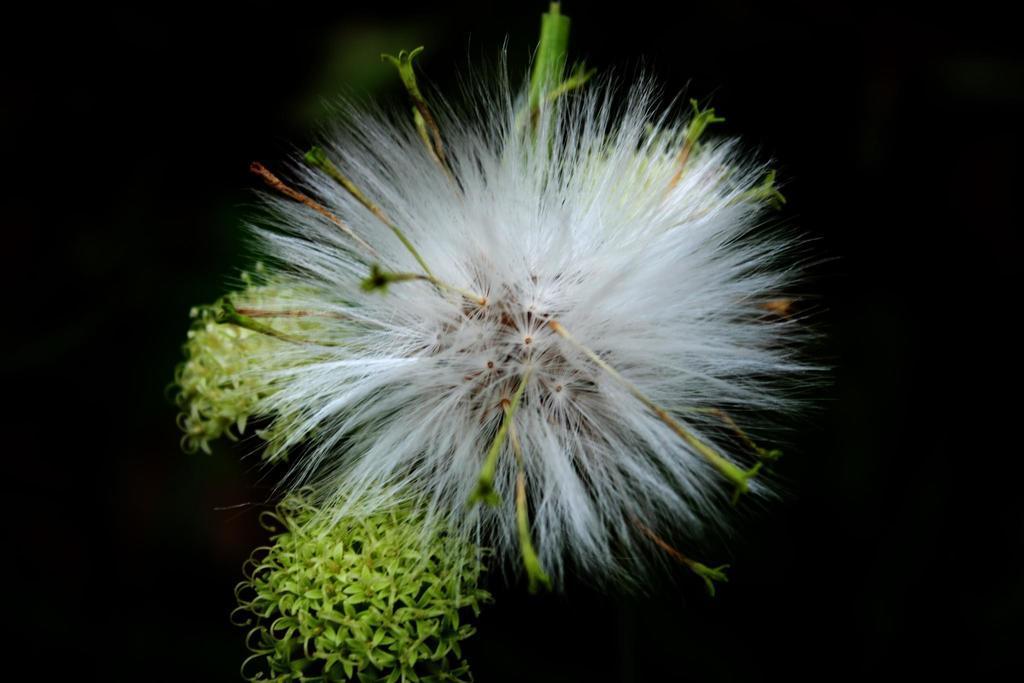How would you summarize this image in a sentence or two? In the center of the image we can see the dandelion and green colored flowers. And we can see the dark background. 